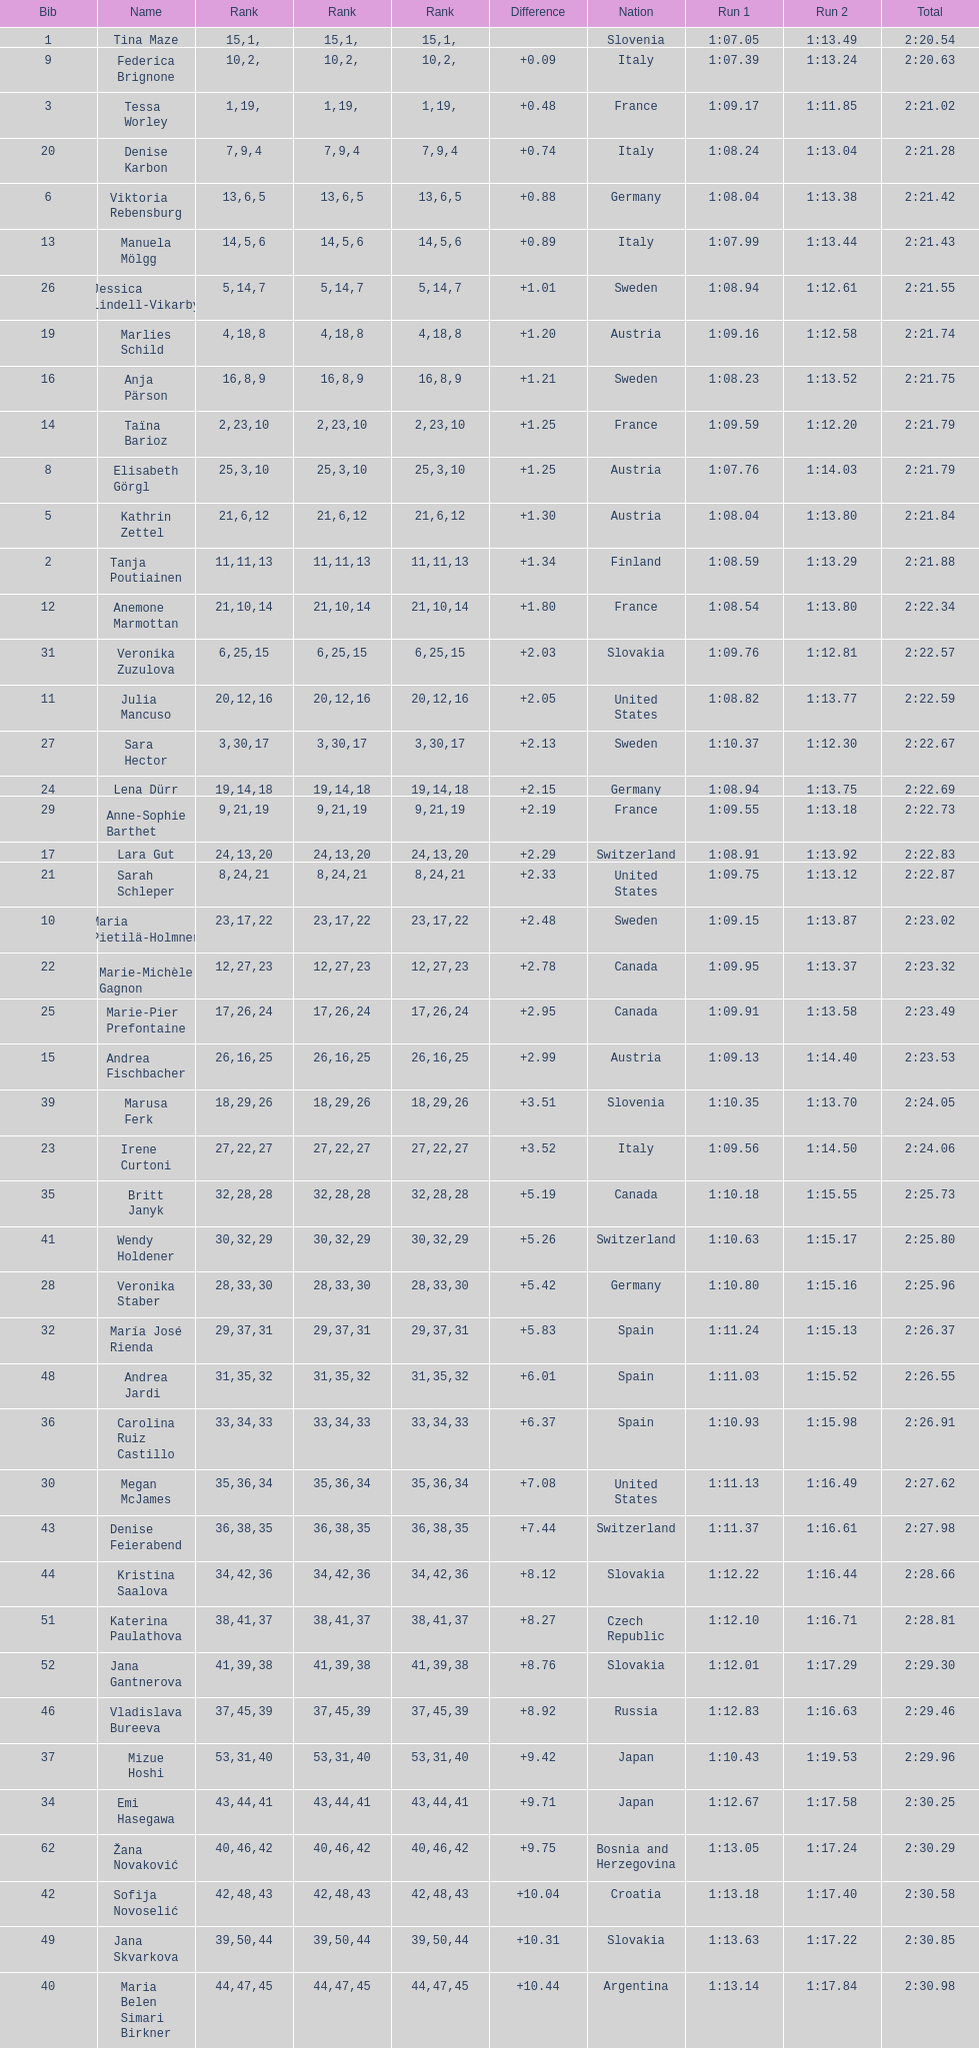Who finished next after federica brignone? Tessa Worley. 